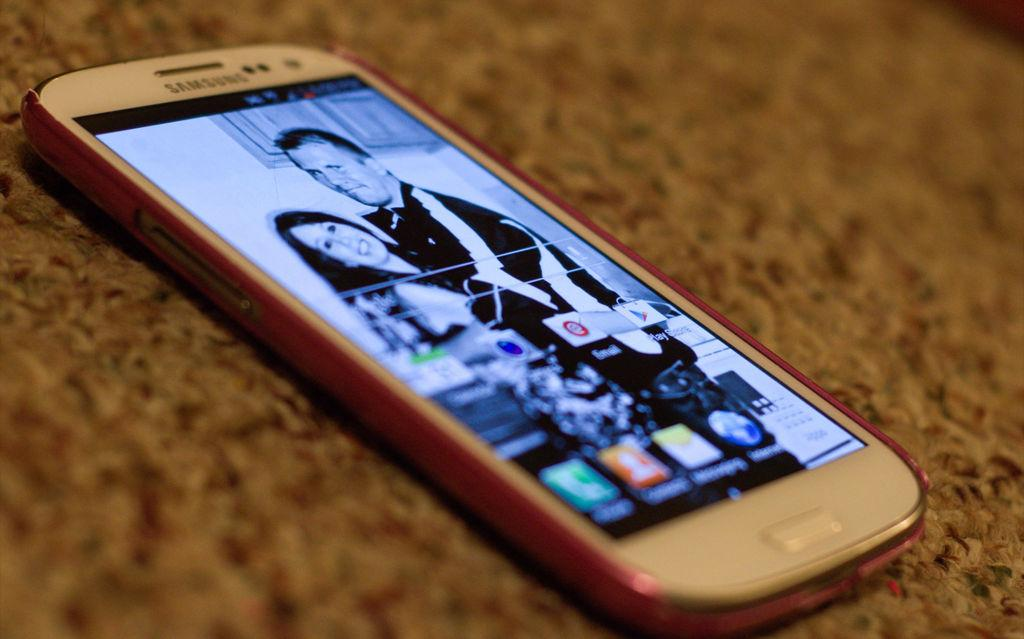<image>
Create a compact narrative representing the image presented. A Samsung phone screen shows a man and woman embracing. 